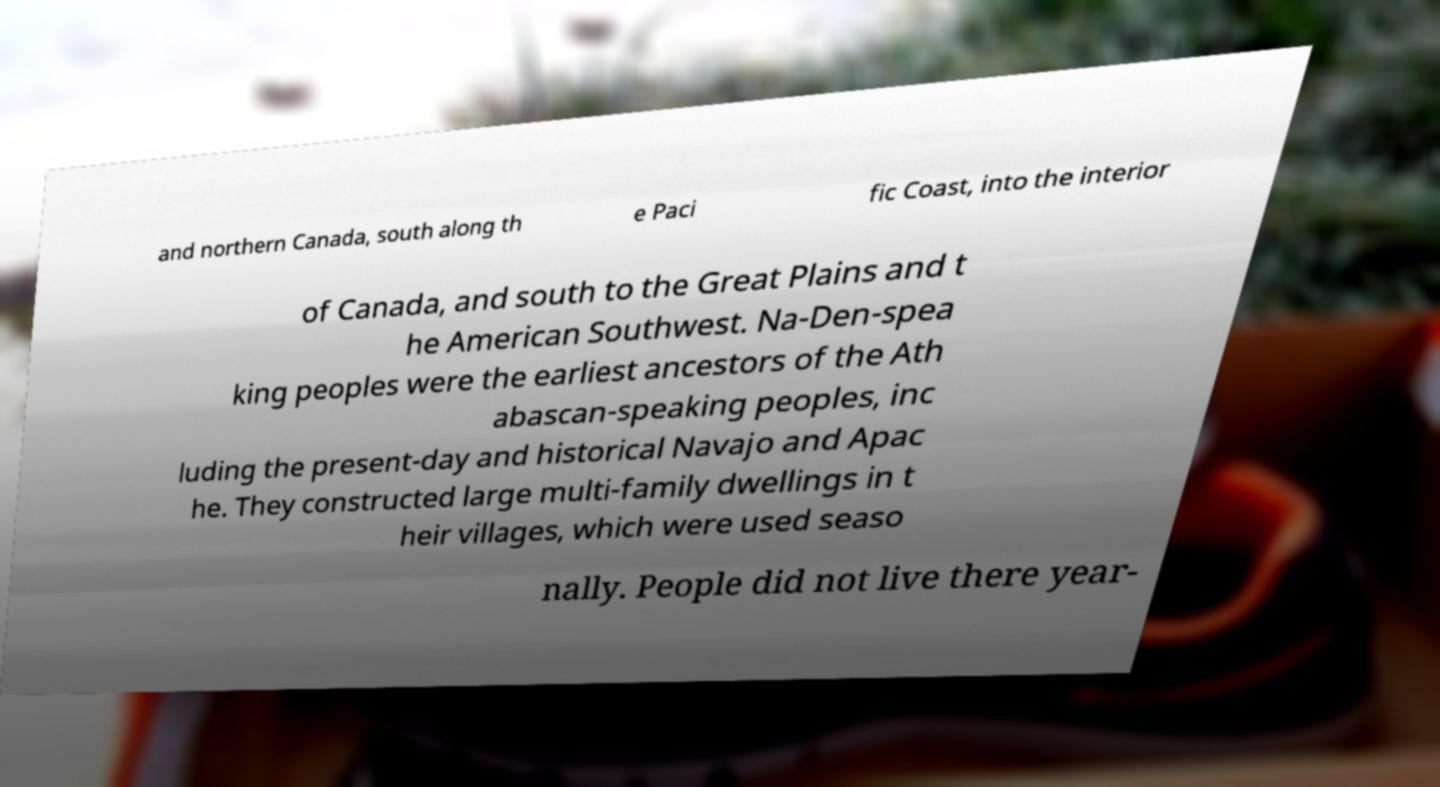There's text embedded in this image that I need extracted. Can you transcribe it verbatim? and northern Canada, south along th e Paci fic Coast, into the interior of Canada, and south to the Great Plains and t he American Southwest. Na-Den-spea king peoples were the earliest ancestors of the Ath abascan-speaking peoples, inc luding the present-day and historical Navajo and Apac he. They constructed large multi-family dwellings in t heir villages, which were used seaso nally. People did not live there year- 